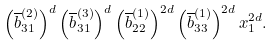<formula> <loc_0><loc_0><loc_500><loc_500>\left ( \overline { b } _ { 3 1 } ^ { ( 2 ) } \right ) ^ { d } \left ( \overline { b } _ { 3 1 } ^ { ( 3 ) } \right ) ^ { d } \left ( \overline { b } _ { 2 2 } ^ { ( 1 ) } \right ) ^ { 2 d } \left ( \overline { b } _ { 3 3 } ^ { ( 1 ) } \right ) ^ { 2 d } x _ { 1 } ^ { 2 d } .</formula> 